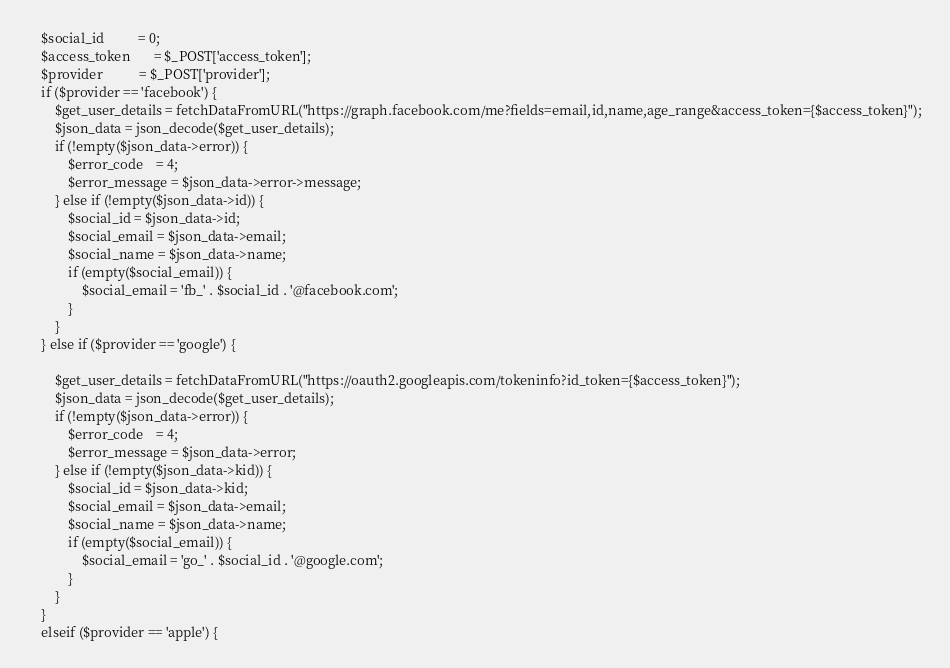<code> <loc_0><loc_0><loc_500><loc_500><_PHP_>	$social_id          = 0;
    $access_token       = $_POST['access_token'];
    $provider           = $_POST['provider'];
    if ($provider == 'facebook') {
    	$get_user_details = fetchDataFromURL("https://graph.facebook.com/me?fields=email,id,name,age_range&access_token={$access_token}");
    	$json_data = json_decode($get_user_details);
    	if (!empty($json_data->error)) {
    		$error_code    = 4;
    		$error_message = $json_data->error->message;
    	} else if (!empty($json_data->id)) {
    		$social_id = $json_data->id;
    		$social_email = $json_data->email;
    		$social_name = $json_data->name;
    		if (empty($social_email)) {
    			$social_email = 'fb_' . $social_id . '@facebook.com';
    		}
    	}
    } else if ($provider == 'google') {
        
		$get_user_details = fetchDataFromURL("https://oauth2.googleapis.com/tokeninfo?id_token={$access_token}");
		$json_data = json_decode($get_user_details);
		if (!empty($json_data->error)) {
    		$error_code    = 4;
    		$error_message = $json_data->error;
    	} else if (!empty($json_data->kid)) {
    		$social_id = $json_data->kid;
    		$social_email = $json_data->email;
    		$social_name = $json_data->name;
    		if (empty($social_email)) {
    			$social_email = 'go_' . $social_id . '@google.com';
    		}
    	}
    }
    elseif ($provider == 'apple') {</code> 